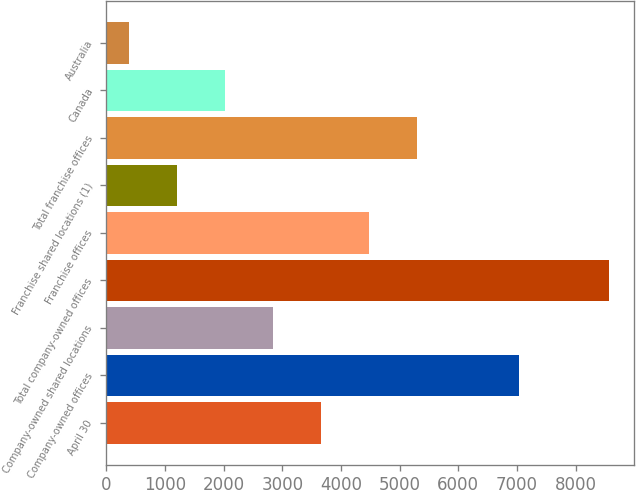Convert chart to OTSL. <chart><loc_0><loc_0><loc_500><loc_500><bar_chart><fcel>April 30<fcel>Company-owned offices<fcel>Company-owned shared locations<fcel>Total company-owned offices<fcel>Franchise offices<fcel>Franchise shared locations (1)<fcel>Total franchise offices<fcel>Canada<fcel>Australia<nl><fcel>3655.2<fcel>7029<fcel>2835.9<fcel>8571<fcel>4474.5<fcel>1197.3<fcel>5293.8<fcel>2016.6<fcel>378<nl></chart> 